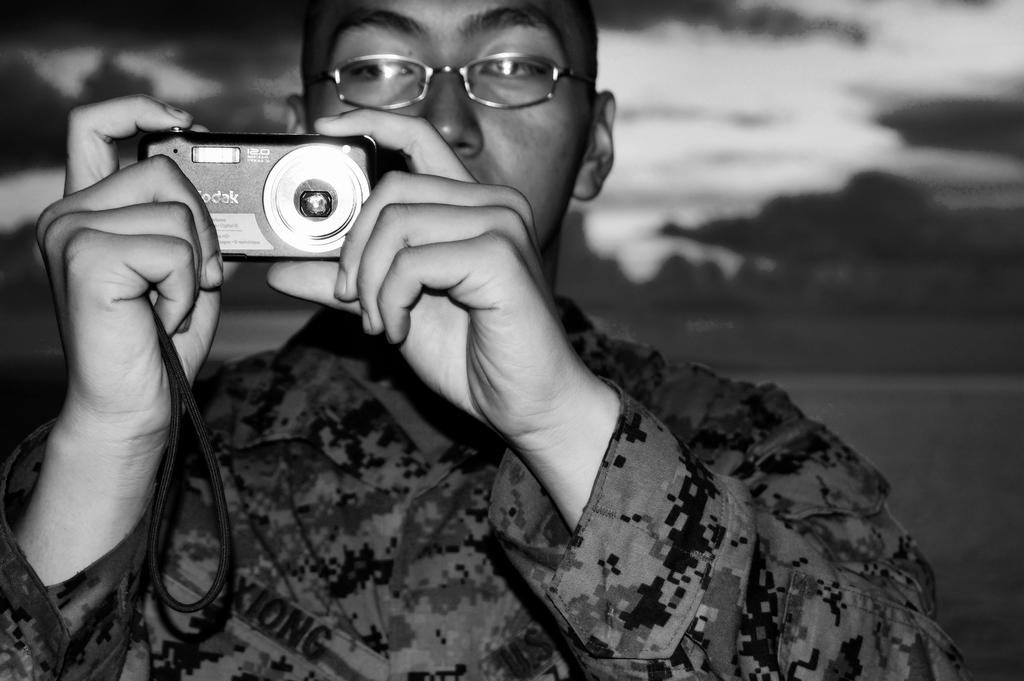What is the main subject of the picture? The main subject of the picture is a man. What is the man holding in his hand? The man is holding a camera in his hand. What type of glove is the man wearing in the picture? There is no glove visible in the picture; the man is holding a camera in his hand. 